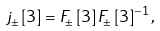<formula> <loc_0><loc_0><loc_500><loc_500>j _ { \pm } \left [ 3 \right ] = F _ { \pm } \left [ 3 \right ] F _ { \pm } \left [ 3 \right ] ^ { - 1 } , \text { }</formula> 